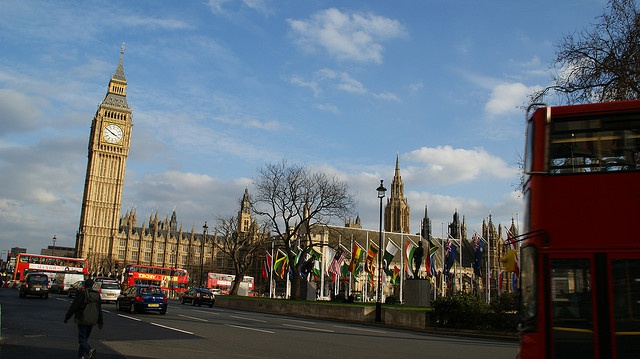Describe the objects in this image and their specific colors. I can see bus in gray, black, maroon, and olive tones, bus in gray, black, maroon, red, and olive tones, people in gray, black, and maroon tones, bus in gray, black, lightgray, maroon, and brown tones, and car in gray, black, navy, and maroon tones in this image. 